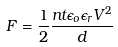Convert formula to latex. <formula><loc_0><loc_0><loc_500><loc_500>F = \frac { 1 } { 2 } \frac { n t \epsilon _ { o } \epsilon _ { r } V ^ { 2 } } { d }</formula> 